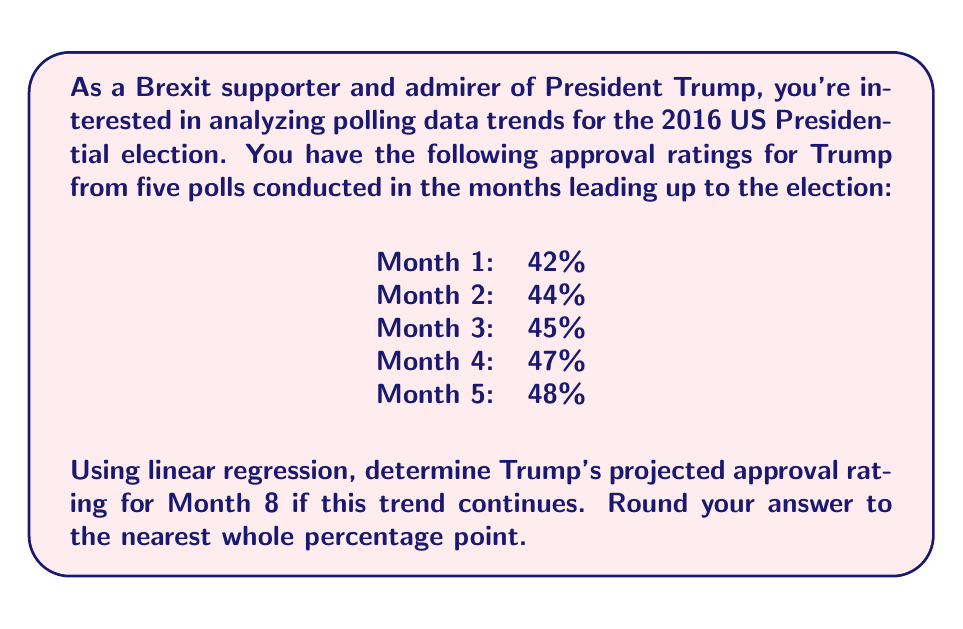Help me with this question. To solve this problem using linear regression, we'll follow these steps:

1) Let x represent the month number and y represent the approval rating.

2) Calculate the means of x and y:
   $\bar{x} = \frac{1+2+3+4+5}{5} = 3$
   $\bar{y} = \frac{42+44+45+47+48}{5} = 45.2$

3) Calculate the slope (m) using the formula:
   $m = \frac{\sum(x_i - \bar{x})(y_i - \bar{y})}{\sum(x_i - \bar{x})^2}$

   $\sum(x_i - \bar{x})(y_i - \bar{y}) = (-2)(-3.2) + (-1)(-1.2) + (0)(-0.2) + (1)(1.8) + (2)(2.8) = 14.2$
   $\sum(x_i - \bar{x})^2 = (-2)^2 + (-1)^2 + 0^2 + 1^2 + 2^2 = 10$

   $m = \frac{14.2}{10} = 1.42$

4) Calculate the y-intercept (b) using the formula:
   $b = \bar{y} - m\bar{x} = 45.2 - (1.42)(3) = 40.94$

5) The linear regression equation is:
   $y = 1.42x + 40.94$

6) To predict the approval rating for Month 8, substitute x = 8:
   $y = 1.42(8) + 40.94 = 52.3$

7) Rounding to the nearest whole percentage point:
   52.3% ≈ 52%
Answer: 52% 